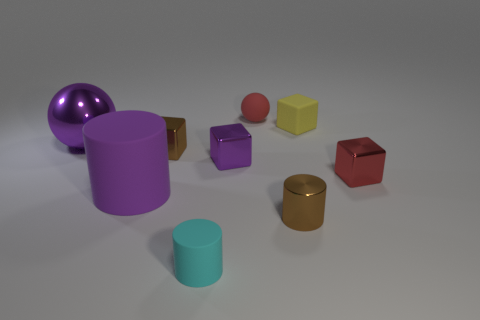Is the number of tiny cyan matte objects on the left side of the small brown block less than the number of tiny red things in front of the large sphere?
Ensure brevity in your answer.  Yes. What number of tiny things have the same material as the large purple sphere?
Provide a short and direct response. 4. There is a yellow matte object; is its size the same as the ball on the left side of the small red rubber ball?
Your answer should be compact. No. There is a cylinder that is the same color as the metallic ball; what is it made of?
Ensure brevity in your answer.  Rubber. How big is the purple metal object that is to the left of the cylinder left of the small cylinder that is to the left of the tiny red ball?
Offer a very short reply. Large. Is the number of tiny red things in front of the tiny yellow rubber cube greater than the number of big matte objects right of the small red shiny thing?
Offer a terse response. Yes. How many brown cylinders are to the left of the rubber cylinder behind the small cyan matte cylinder?
Your answer should be very brief. 0. Are there any large matte objects that have the same color as the large shiny sphere?
Offer a terse response. Yes. Do the red rubber object and the purple sphere have the same size?
Keep it short and to the point. No. Is the color of the metallic sphere the same as the large matte object?
Your answer should be compact. Yes. 